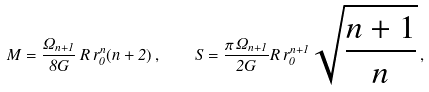Convert formula to latex. <formula><loc_0><loc_0><loc_500><loc_500>M = \frac { \Omega _ { n + 1 } } { 8 G } \, R \, r _ { 0 } ^ { n } ( n + 2 ) \, , \quad S = \frac { \pi \, \Omega _ { n + 1 } } { 2 G } R \, r _ { 0 } ^ { n + 1 } \sqrt { \frac { n + 1 } { n } } \, ,</formula> 